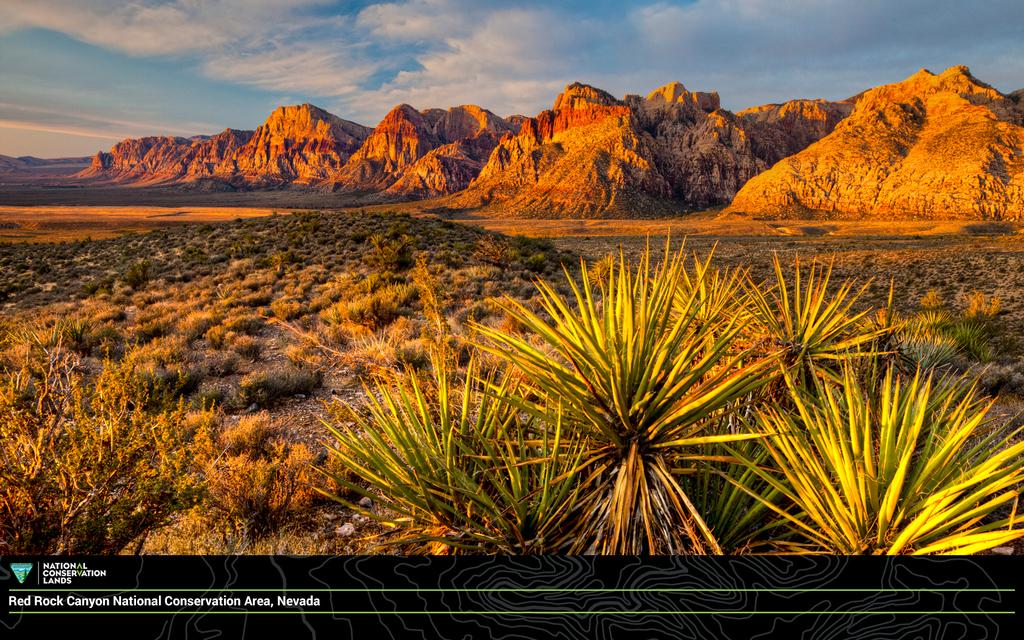What type of natural landform can be seen in the image? There are mountains in the image. What type of vegetation is present in the image? There are plants and grass in the image. What is visible in the sky in the image? The sky is visible in the image, and there are clouds present. Can you describe the logo at the bottom of the image? There is a logo with text at the bottom of the image. What type of soda is being advertised in the image? There is no soda being advertised in the image; it features mountains, plants, grass, clouds, and a logo with text. How many rooms are visible in the image? There are no rooms visible in the image; it is an outdoor scene with mountains, plants, grass, clouds, and a logo with text. 